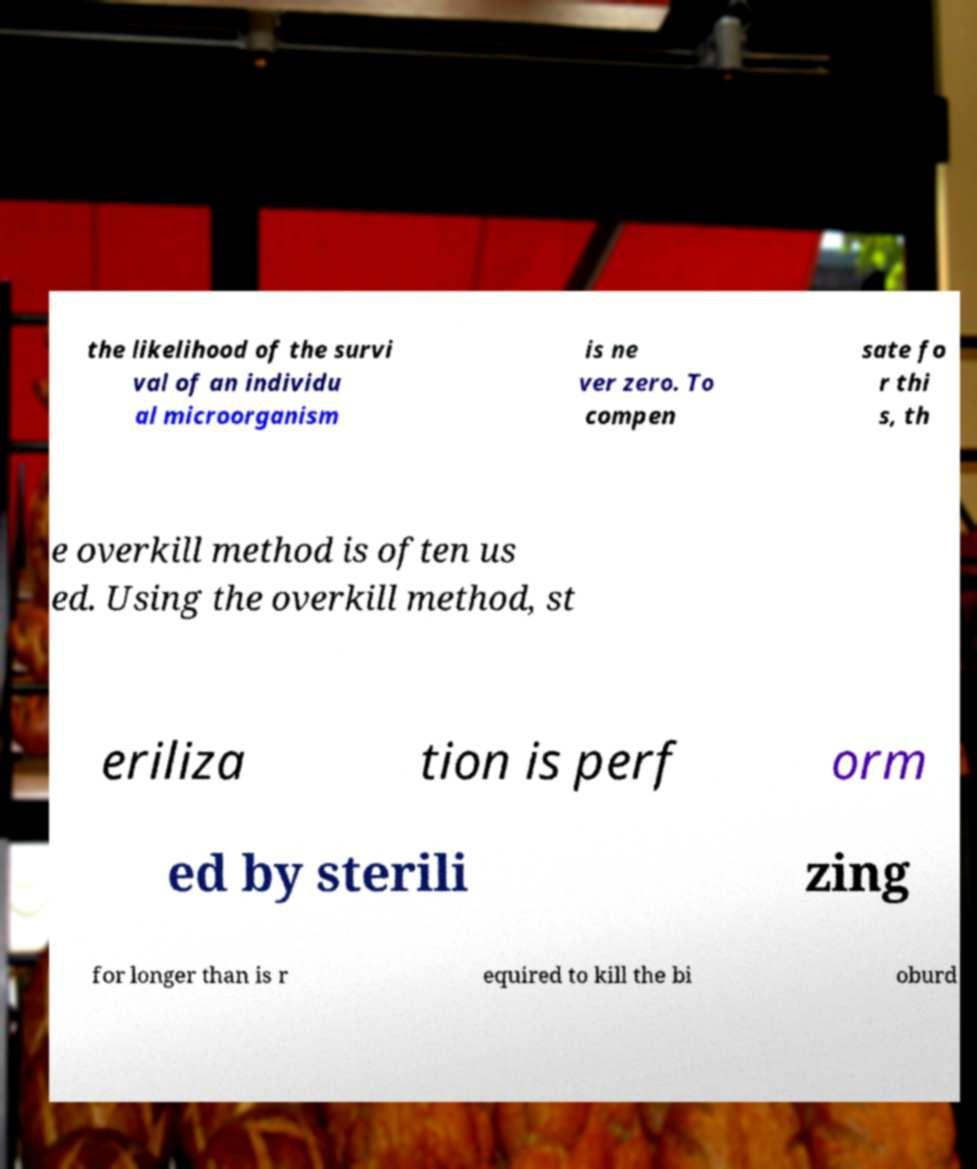There's text embedded in this image that I need extracted. Can you transcribe it verbatim? the likelihood of the survi val of an individu al microorganism is ne ver zero. To compen sate fo r thi s, th e overkill method is often us ed. Using the overkill method, st eriliza tion is perf orm ed by sterili zing for longer than is r equired to kill the bi oburd 